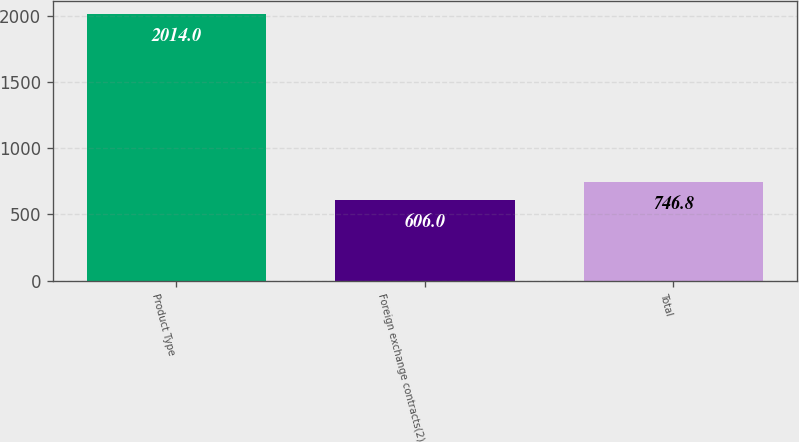Convert chart to OTSL. <chart><loc_0><loc_0><loc_500><loc_500><bar_chart><fcel>Product Type<fcel>Foreign exchange contracts(2)<fcel>Total<nl><fcel>2014<fcel>606<fcel>746.8<nl></chart> 